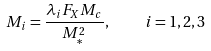Convert formula to latex. <formula><loc_0><loc_0><loc_500><loc_500>M _ { i } = \frac { \lambda _ { i } F _ { X } M _ { c } } { M ^ { 2 } _ { * } } , \quad i = 1 , 2 , 3</formula> 